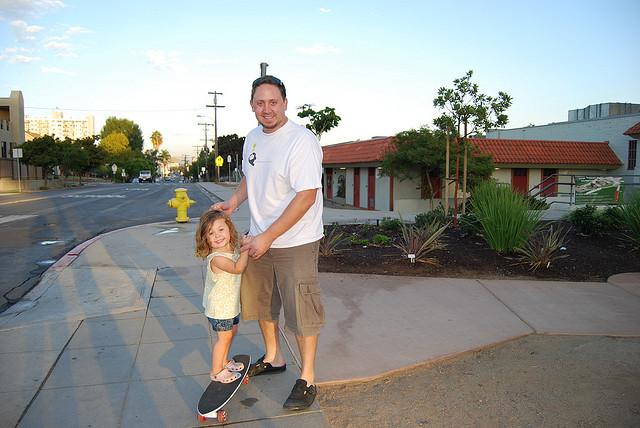What are the reddish and green plants called in the forefront of the planter?

Choices:
A) agapanthus
B) pampas grass
C) flax
D) lily flax 